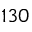<formula> <loc_0><loc_0><loc_500><loc_500>1 3 0</formula> 